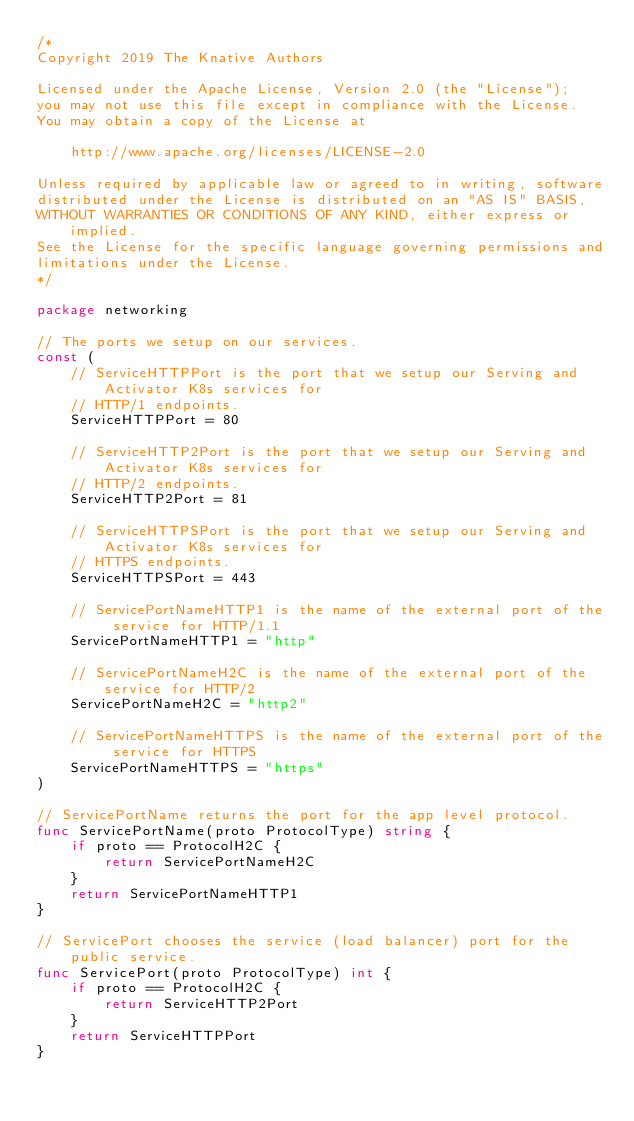Convert code to text. <code><loc_0><loc_0><loc_500><loc_500><_Go_>/*
Copyright 2019 The Knative Authors

Licensed under the Apache License, Version 2.0 (the "License");
you may not use this file except in compliance with the License.
You may obtain a copy of the License at

    http://www.apache.org/licenses/LICENSE-2.0

Unless required by applicable law or agreed to in writing, software
distributed under the License is distributed on an "AS IS" BASIS,
WITHOUT WARRANTIES OR CONDITIONS OF ANY KIND, either express or implied.
See the License for the specific language governing permissions and
limitations under the License.
*/

package networking

// The ports we setup on our services.
const (
	// ServiceHTTPPort is the port that we setup our Serving and Activator K8s services for
	// HTTP/1 endpoints.
	ServiceHTTPPort = 80

	// ServiceHTTP2Port is the port that we setup our Serving and Activator K8s services for
	// HTTP/2 endpoints.
	ServiceHTTP2Port = 81

	// ServiceHTTPSPort is the port that we setup our Serving and Activator K8s services for
	// HTTPS endpoints.
	ServiceHTTPSPort = 443

	// ServicePortNameHTTP1 is the name of the external port of the service for HTTP/1.1
	ServicePortNameHTTP1 = "http"

	// ServicePortNameH2C is the name of the external port of the service for HTTP/2
	ServicePortNameH2C = "http2"

	// ServicePortNameHTTPS is the name of the external port of the service for HTTPS
	ServicePortNameHTTPS = "https"
)

// ServicePortName returns the port for the app level protocol.
func ServicePortName(proto ProtocolType) string {
	if proto == ProtocolH2C {
		return ServicePortNameH2C
	}
	return ServicePortNameHTTP1
}

// ServicePort chooses the service (load balancer) port for the public service.
func ServicePort(proto ProtocolType) int {
	if proto == ProtocolH2C {
		return ServiceHTTP2Port
	}
	return ServiceHTTPPort
}
</code> 